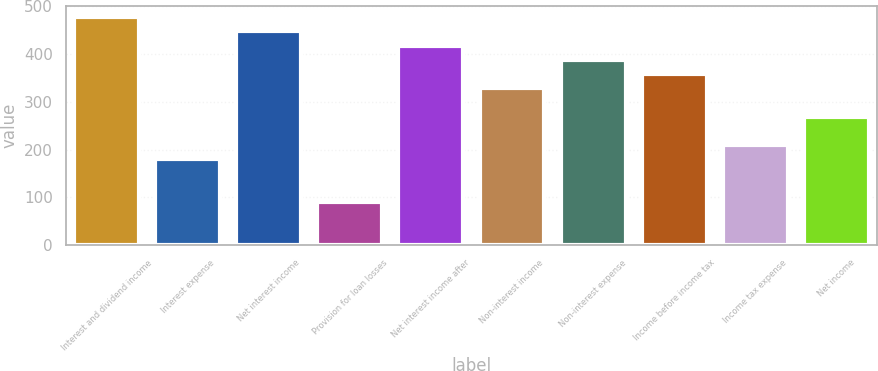Convert chart to OTSL. <chart><loc_0><loc_0><loc_500><loc_500><bar_chart><fcel>Interest and dividend income<fcel>Interest expense<fcel>Net interest income<fcel>Provision for loan losses<fcel>Net interest income after<fcel>Non-interest income<fcel>Non-interest expense<fcel>Income before income tax<fcel>Income tax expense<fcel>Net income<nl><fcel>477.77<fcel>179.27<fcel>447.92<fcel>89.72<fcel>418.07<fcel>328.52<fcel>388.22<fcel>358.37<fcel>209.12<fcel>268.82<nl></chart> 